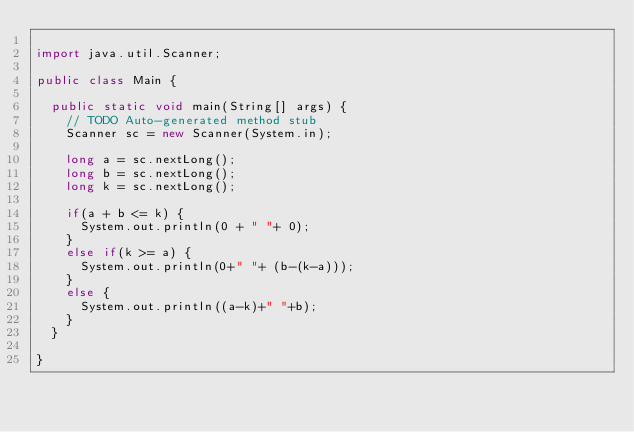<code> <loc_0><loc_0><loc_500><loc_500><_Java_>
import java.util.Scanner;

public class Main {

	public static void main(String[] args) {
		// TODO Auto-generated method stub
		Scanner sc = new Scanner(System.in);
		
		long a = sc.nextLong();
		long b = sc.nextLong();
		long k = sc.nextLong();
		
		if(a + b <= k) {
			System.out.println(0 + " "+ 0);
		}
		else if(k >= a) {
			System.out.println(0+" "+ (b-(k-a)));
		}
		else {
			System.out.println((a-k)+" "+b);
		}
	}

}
</code> 